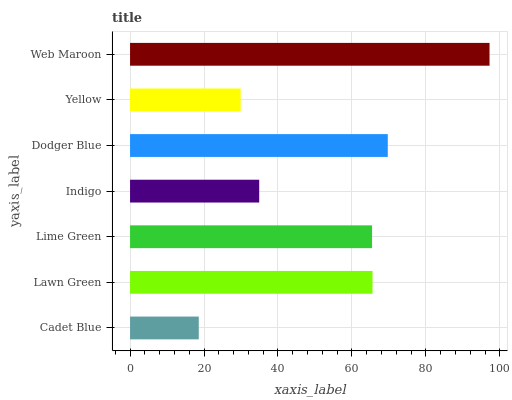Is Cadet Blue the minimum?
Answer yes or no. Yes. Is Web Maroon the maximum?
Answer yes or no. Yes. Is Lawn Green the minimum?
Answer yes or no. No. Is Lawn Green the maximum?
Answer yes or no. No. Is Lawn Green greater than Cadet Blue?
Answer yes or no. Yes. Is Cadet Blue less than Lawn Green?
Answer yes or no. Yes. Is Cadet Blue greater than Lawn Green?
Answer yes or no. No. Is Lawn Green less than Cadet Blue?
Answer yes or no. No. Is Lime Green the high median?
Answer yes or no. Yes. Is Lime Green the low median?
Answer yes or no. Yes. Is Cadet Blue the high median?
Answer yes or no. No. Is Cadet Blue the low median?
Answer yes or no. No. 